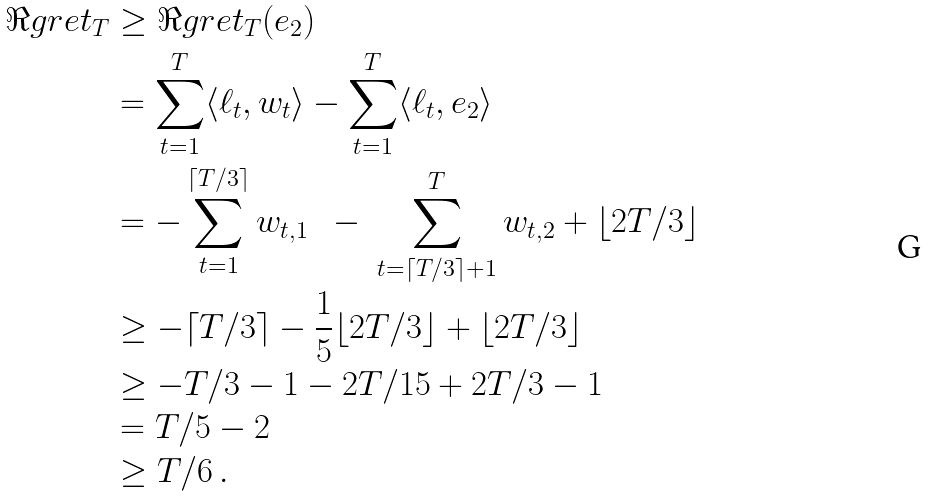Convert formula to latex. <formula><loc_0><loc_0><loc_500><loc_500>\Re g r e t _ { T } & \geq \Re g r e t _ { T } ( e _ { 2 } ) \\ & = \sum _ { t = 1 } ^ { T } \langle \ell _ { t } , w _ { t } \rangle - \sum _ { t = 1 } ^ { T } \langle \ell _ { t } , e _ { 2 } \rangle \\ & = - \sum _ { t = 1 } ^ { \lceil T / 3 \rceil } w _ { t , 1 } \ \ - \ \sum _ { t = \lceil T / 3 \rceil + 1 } ^ { T } w _ { t , 2 } + \lfloor 2 T / 3 \rfloor \\ & \geq - \lceil T / 3 \rceil - \frac { 1 } { 5 } \lfloor 2 T / 3 \rfloor + \lfloor 2 T / 3 \rfloor \\ & \geq - T / 3 - 1 - 2 T / 1 5 + 2 T / 3 - 1 \\ & = T / 5 - 2 \\ & \geq T / 6 \, .</formula> 